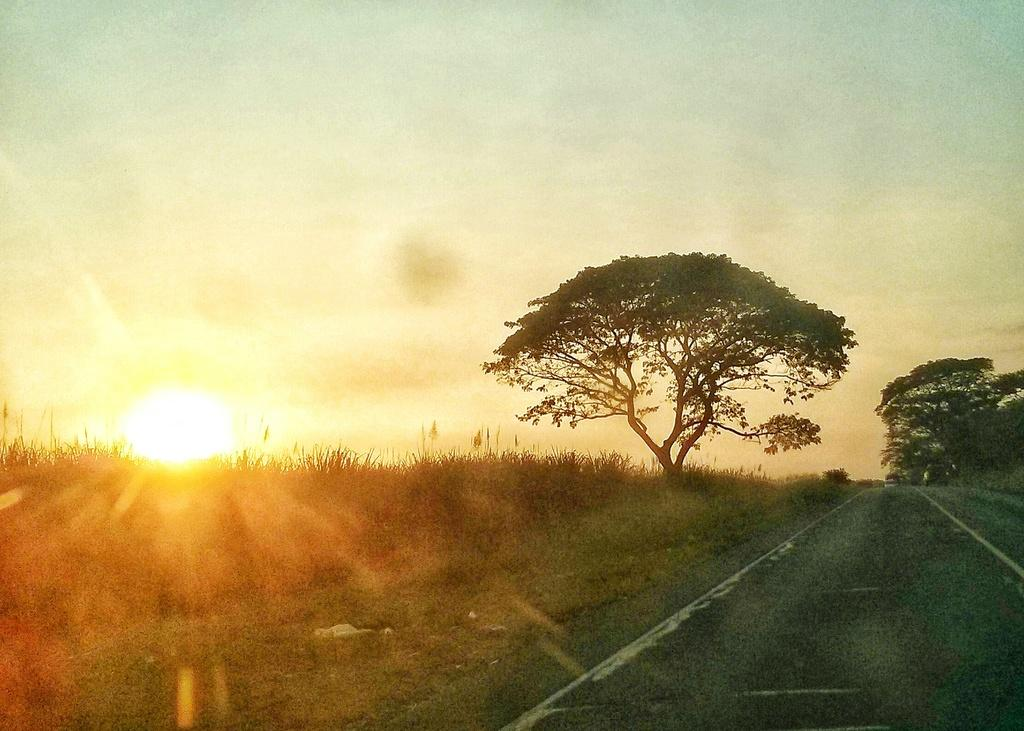What type of pathway is located on the right side of the image? There is a road on the right side of the image. What natural element is in the middle of the image? There is a tree in the middle of the image. What celestial body is visible on the left side of the image? The sun is visible in the sky on the left side of the image. What type of statement is written on the tree in the image? There is no statement written on the tree in the image; it is a natural element with no text or markings. How many patches can be seen on the sun in the image? There are no patches visible on the sun in the image; it appears as a single, unblemished celestial body. 